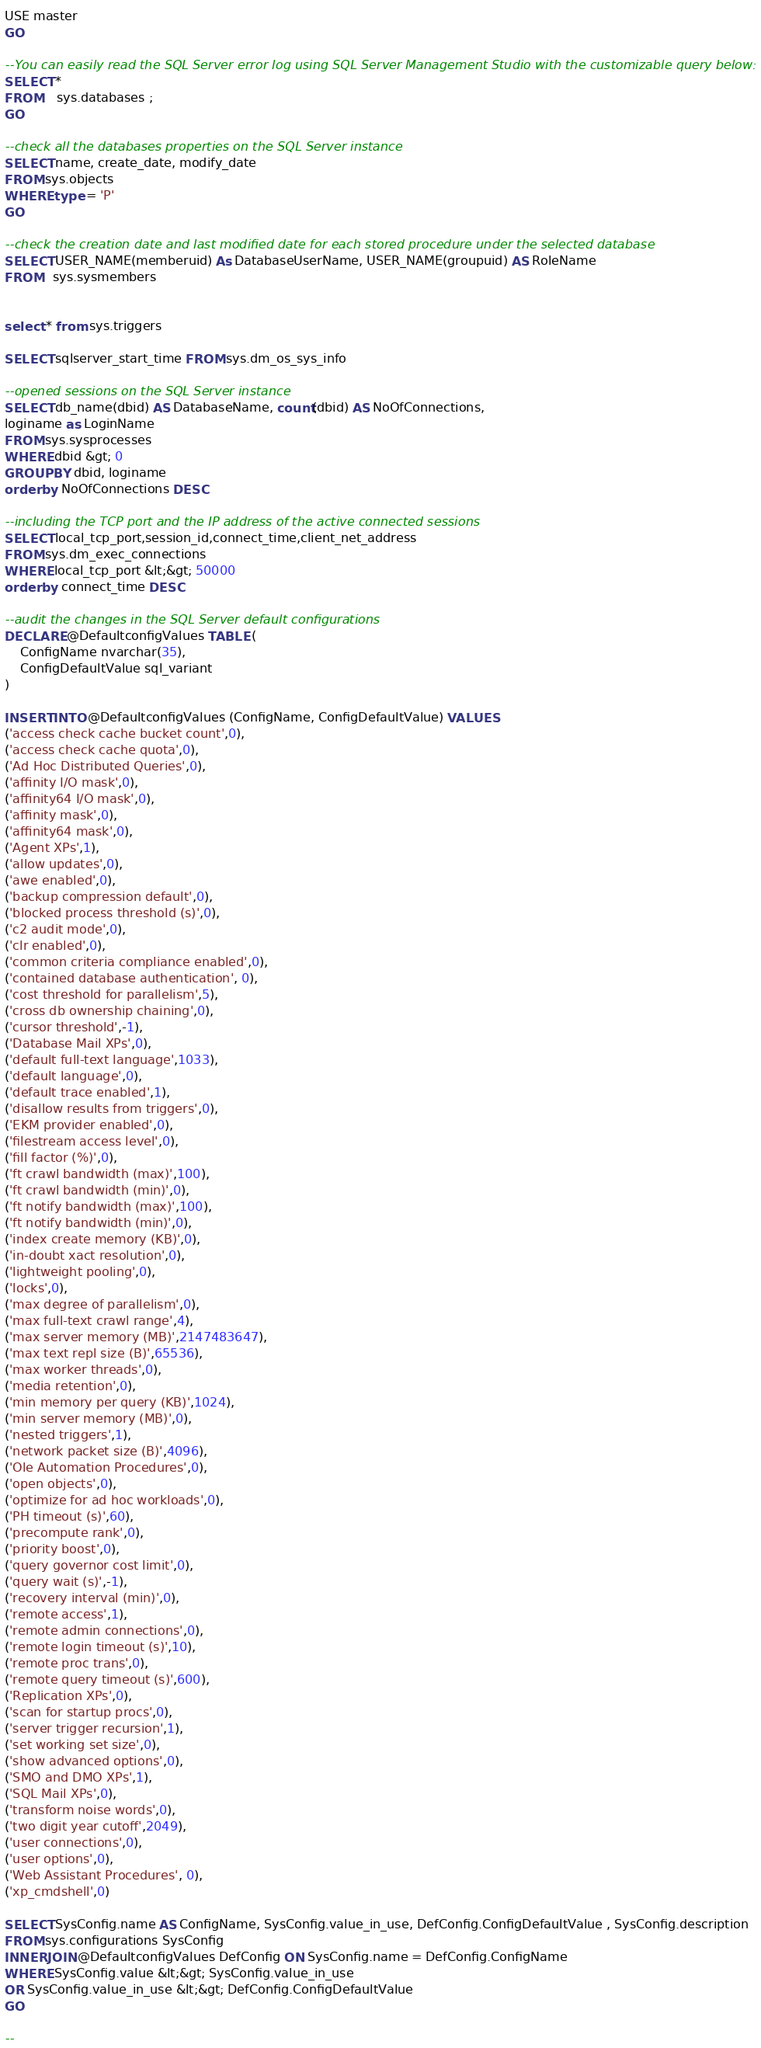<code> <loc_0><loc_0><loc_500><loc_500><_SQL_>USE master
GO

--You can easily read the SQL Server error log using SQL Server Management Studio with the customizable query below:
SELECT *
FROM    sys.databases ;
GO

--check all the databases properties on the SQL Server instance
SELECT name, create_date, modify_date
FROM sys.objects 
WHERE type = 'P'
GO

--check the creation date and last modified date for each stored procedure under the selected database
SELECT USER_NAME(memberuid) As DatabaseUserName, USER_NAME(groupuid) AS RoleName
FROM   sys.sysmembers


select * from sys.triggers

SELECT sqlserver_start_time FROM sys.dm_os_sys_info

--opened sessions on the SQL Server instance 
SELECT db_name(dbid) AS DatabaseName, count(dbid) AS NoOfConnections,
loginame as LoginName
FROM sys.sysprocesses
WHERE dbid &gt; 0
GROUP BY dbid, loginame
order by NoOfConnections DESC

--including the TCP port and the IP address of the active connected sessions 
SELECT local_tcp_port,session_id,connect_time,client_net_address 
FROM sys.dm_exec_connections 
WHERE local_tcp_port &lt;&gt; 50000
order by connect_time DESC

--audit the changes in the SQL Server default configurations
DECLARE @DefaultconfigValues TABLE (
    ConfigName nvarchar(35),
    ConfigDefaultValue sql_variant
)
 
INSERT INTO @DefaultconfigValues (ConfigName, ConfigDefaultValue) VALUES
('access check cache bucket count',0),
('access check cache quota',0),
('Ad Hoc Distributed Queries',0),
('affinity I/O mask',0),
('affinity64 I/O mask',0),
('affinity mask',0),
('affinity64 mask',0),
('Agent XPs',1),
('allow updates',0),
('awe enabled',0),
('backup compression default',0),
('blocked process threshold (s)',0),
('c2 audit mode',0),
('clr enabled',0),
('common criteria compliance enabled',0),
('contained database authentication', 0), 
('cost threshold for parallelism',5),
('cross db ownership chaining',0),
('cursor threshold',-1),
('Database Mail XPs',0),
('default full-text language',1033),
('default language',0),
('default trace enabled',1),
('disallow results from triggers',0),
('EKM provider enabled',0),
('filestream access level',0),
('fill factor (%)',0),
('ft crawl bandwidth (max)',100),
('ft crawl bandwidth (min)',0),
('ft notify bandwidth (max)',100),
('ft notify bandwidth (min)',0),
('index create memory (KB)',0),
('in-doubt xact resolution',0),
('lightweight pooling',0),
('locks',0),
('max degree of parallelism',0),
('max full-text crawl range',4),
('max server memory (MB)',2147483647),
('max text repl size (B)',65536),
('max worker threads',0),
('media retention',0),
('min memory per query (KB)',1024),
('min server memory (MB)',0),
('nested triggers',1),
('network packet size (B)',4096),
('Ole Automation Procedures',0),
('open objects',0),
('optimize for ad hoc workloads',0),
('PH timeout (s)',60),
('precompute rank',0),
('priority boost',0),
('query governor cost limit',0),
('query wait (s)',-1),
('recovery interval (min)',0),
('remote access',1),
('remote admin connections',0),
('remote login timeout (s)',10),
('remote proc trans',0),
('remote query timeout (s)',600),
('Replication XPs',0),
('scan for startup procs',0),
('server trigger recursion',1),
('set working set size',0),
('show advanced options',0),
('SMO and DMO XPs',1),
('SQL Mail XPs',0),
('transform noise words',0),
('two digit year cutoff',2049),
('user connections',0),
('user options',0),
('Web Assistant Procedures', 0),
('xp_cmdshell',0)
 
SELECT SysConfig.name AS ConfigName, SysConfig.value_in_use, DefConfig.ConfigDefaultValue , SysConfig.description
FROM sys.configurations SysConfig
INNER JOIN @DefaultconfigValues DefConfig ON SysConfig.name = DefConfig.ConfigName
WHERE SysConfig.value &lt;&gt; SysConfig.value_in_use
OR SysConfig.value_in_use &lt;&gt; DefConfig.ConfigDefaultValue
GO

--</code> 